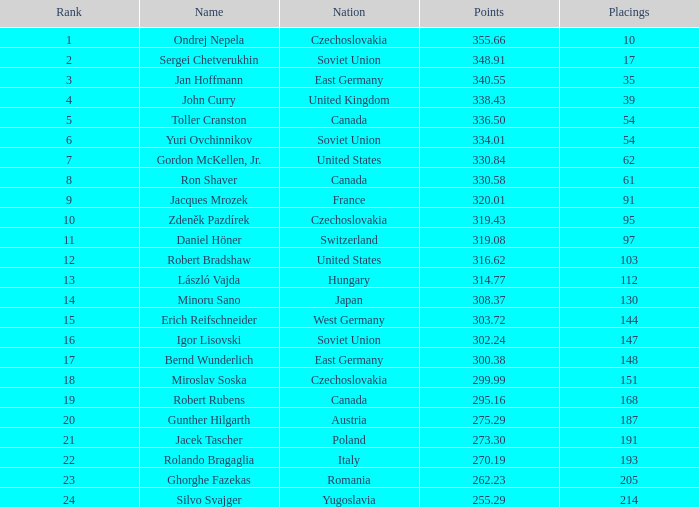Which Rank has a Name of john curry, and Points larger than 338.43? None. 